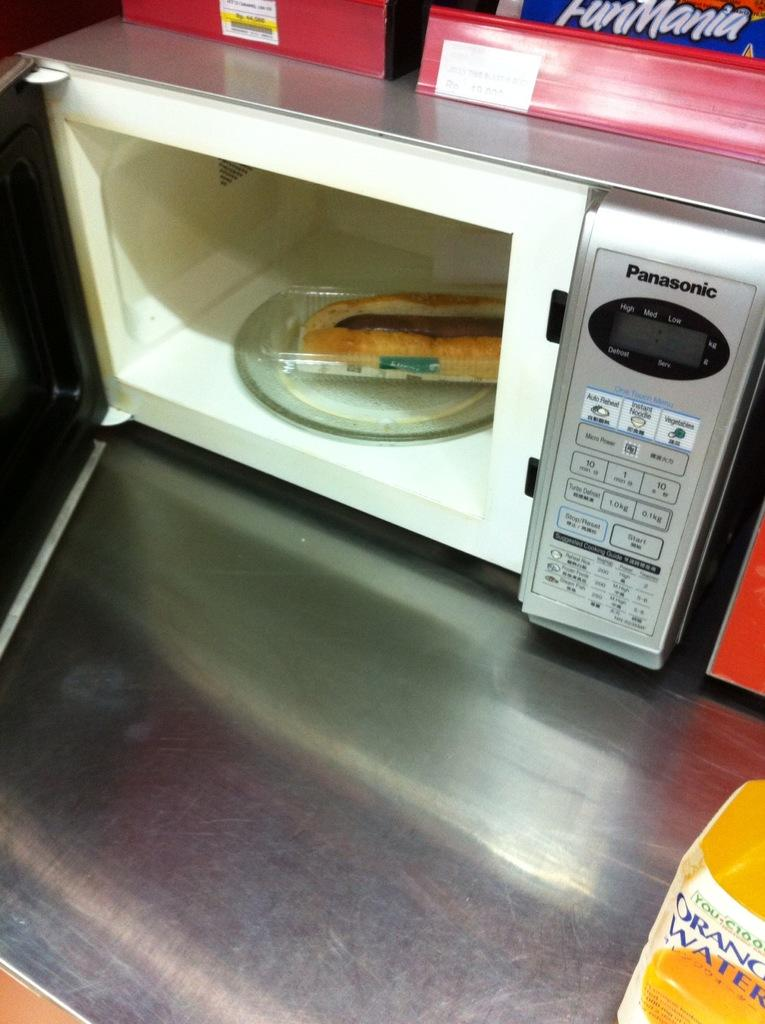What type of appliance is visible in the image? There is a Panasonic oven in the image. What is inside the oven? There is a food item inside the oven. Where is the oven located? The oven is placed on a counter. What else can be seen at the top of the image? There are two red color boxes at the top of the image. What type of horn can be heard in the image? There is no horn or sound present in the image; it is a still image of an oven and boxes. 